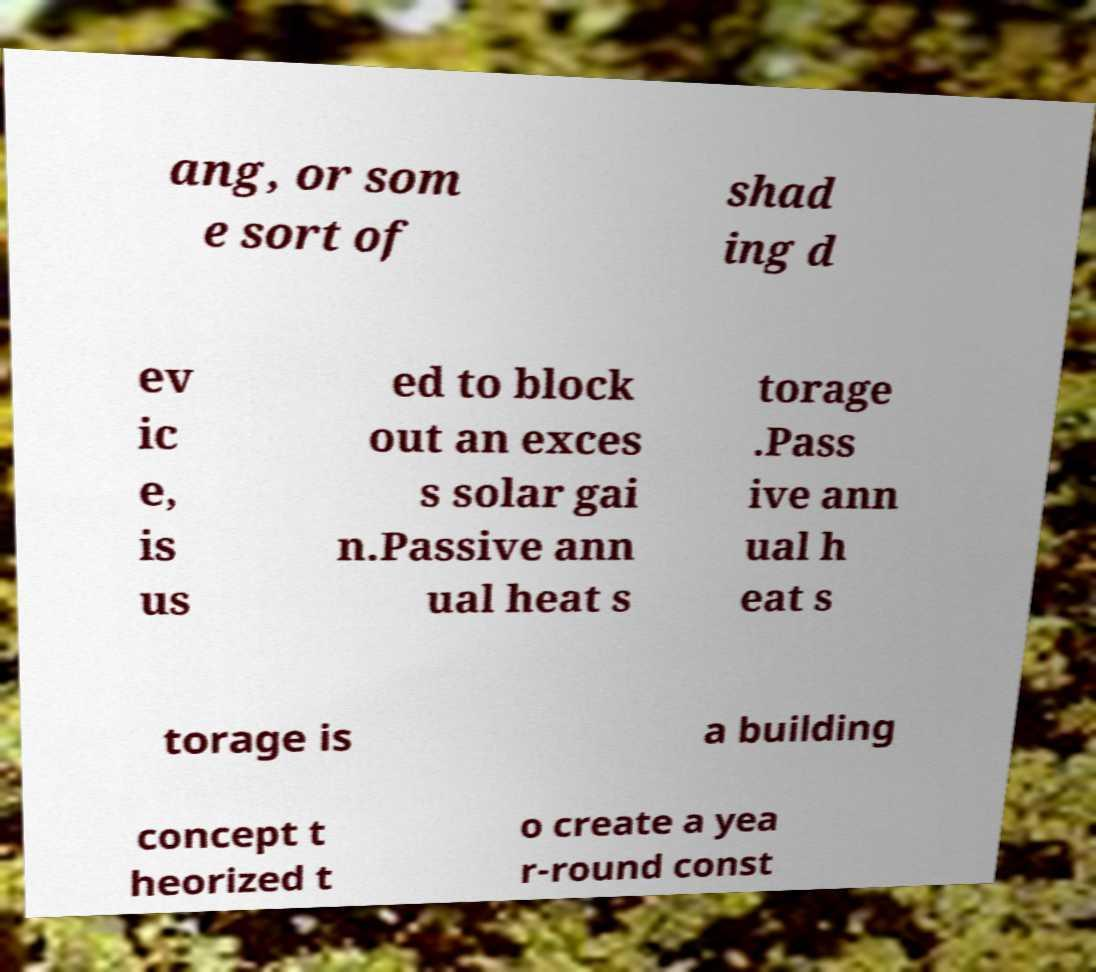Please read and relay the text visible in this image. What does it say? ang, or som e sort of shad ing d ev ic e, is us ed to block out an exces s solar gai n.Passive ann ual heat s torage .Pass ive ann ual h eat s torage is a building concept t heorized t o create a yea r-round const 